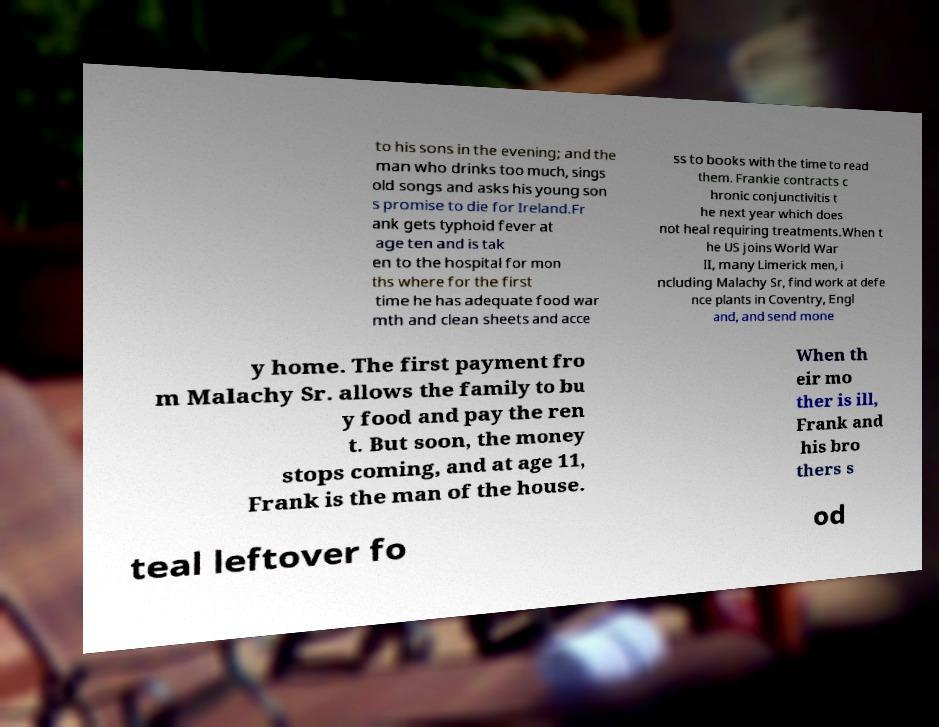There's text embedded in this image that I need extracted. Can you transcribe it verbatim? to his sons in the evening; and the man who drinks too much, sings old songs and asks his young son s promise to die for Ireland.Fr ank gets typhoid fever at age ten and is tak en to the hospital for mon ths where for the first time he has adequate food war mth and clean sheets and acce ss to books with the time to read them. Frankie contracts c hronic conjunctivitis t he next year which does not heal requiring treatments.When t he US joins World War II, many Limerick men, i ncluding Malachy Sr, find work at defe nce plants in Coventry, Engl and, and send mone y home. The first payment fro m Malachy Sr. allows the family to bu y food and pay the ren t. But soon, the money stops coming, and at age 11, Frank is the man of the house. When th eir mo ther is ill, Frank and his bro thers s teal leftover fo od 